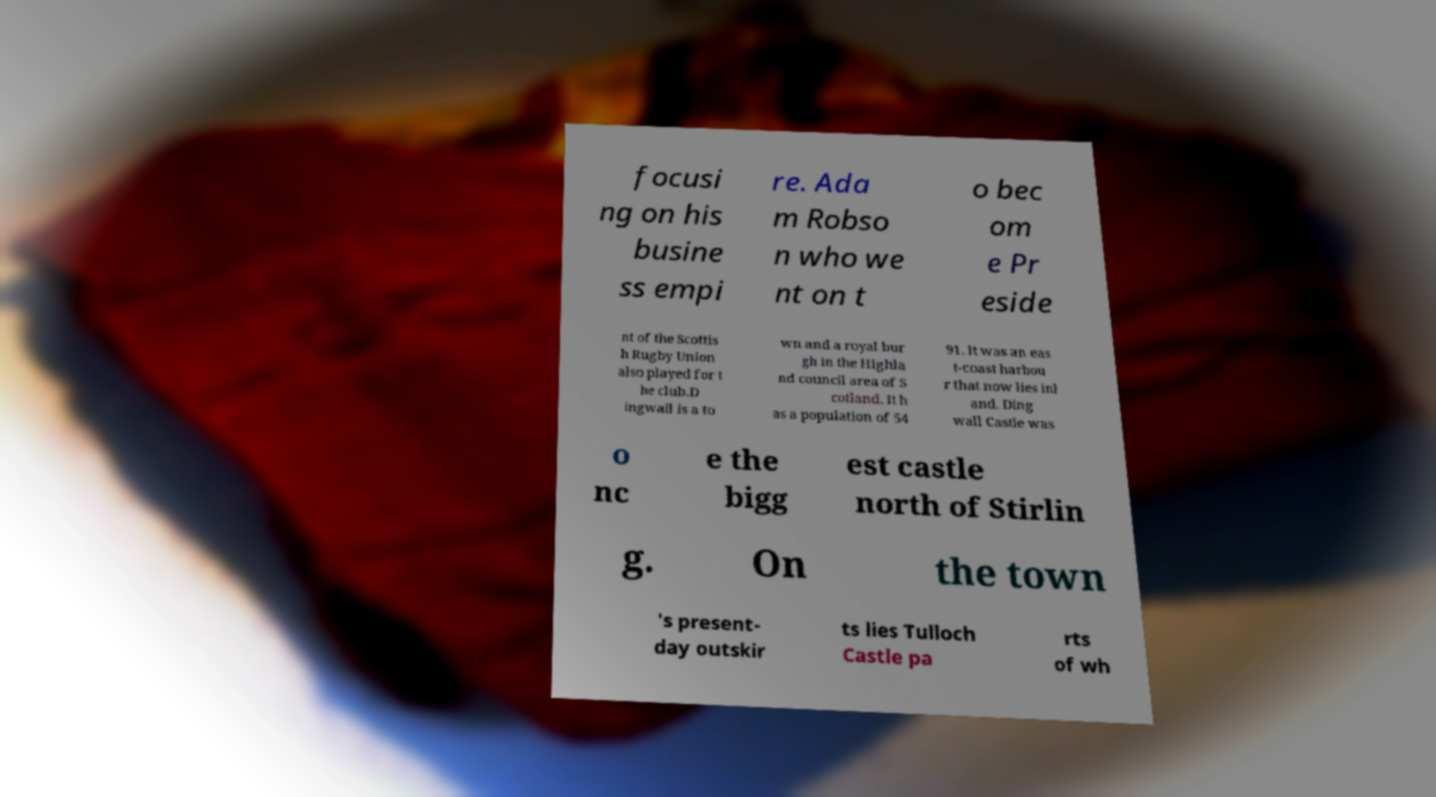Could you extract and type out the text from this image? focusi ng on his busine ss empi re. Ada m Robso n who we nt on t o bec om e Pr eside nt of the Scottis h Rugby Union also played for t he club.D ingwall is a to wn and a royal bur gh in the Highla nd council area of S cotland. It h as a population of 54 91. It was an eas t-coast harbou r that now lies inl and. Ding wall Castle was o nc e the bigg est castle north of Stirlin g. On the town 's present- day outskir ts lies Tulloch Castle pa rts of wh 